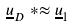<formula> <loc_0><loc_0><loc_500><loc_500>\underline { u } _ { D } * \approx \underline { u } _ { 1 }</formula> 